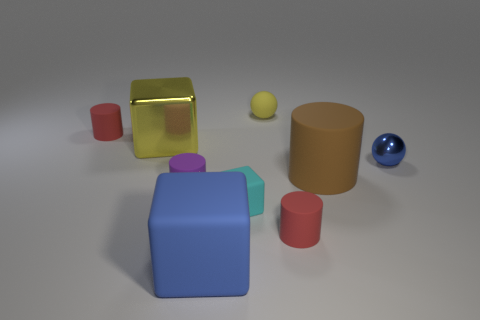Are there any large blocks of the same color as the tiny matte sphere?
Your answer should be very brief. Yes. There is a matte sphere that is the same color as the large metallic cube; what is its size?
Ensure brevity in your answer.  Small. There is a tiny metallic object; does it have the same color as the big rubber thing in front of the large brown matte thing?
Provide a succinct answer. Yes. There is a red cylinder that is to the right of the purple matte cylinder; is its size the same as the blue thing on the left side of the cyan matte object?
Keep it short and to the point. No. Are there any large purple cubes?
Ensure brevity in your answer.  No. The matte cube that is in front of the red cylinder to the right of the yellow rubber thing is what color?
Make the answer very short. Blue. What is the material of the other object that is the same shape as the tiny yellow object?
Ensure brevity in your answer.  Metal. How many red rubber objects are the same size as the brown cylinder?
Give a very brief answer. 0. What is the size of the thing that is the same material as the tiny blue sphere?
Your answer should be compact. Large. What number of tiny red rubber things have the same shape as the cyan rubber object?
Your response must be concise. 0. 